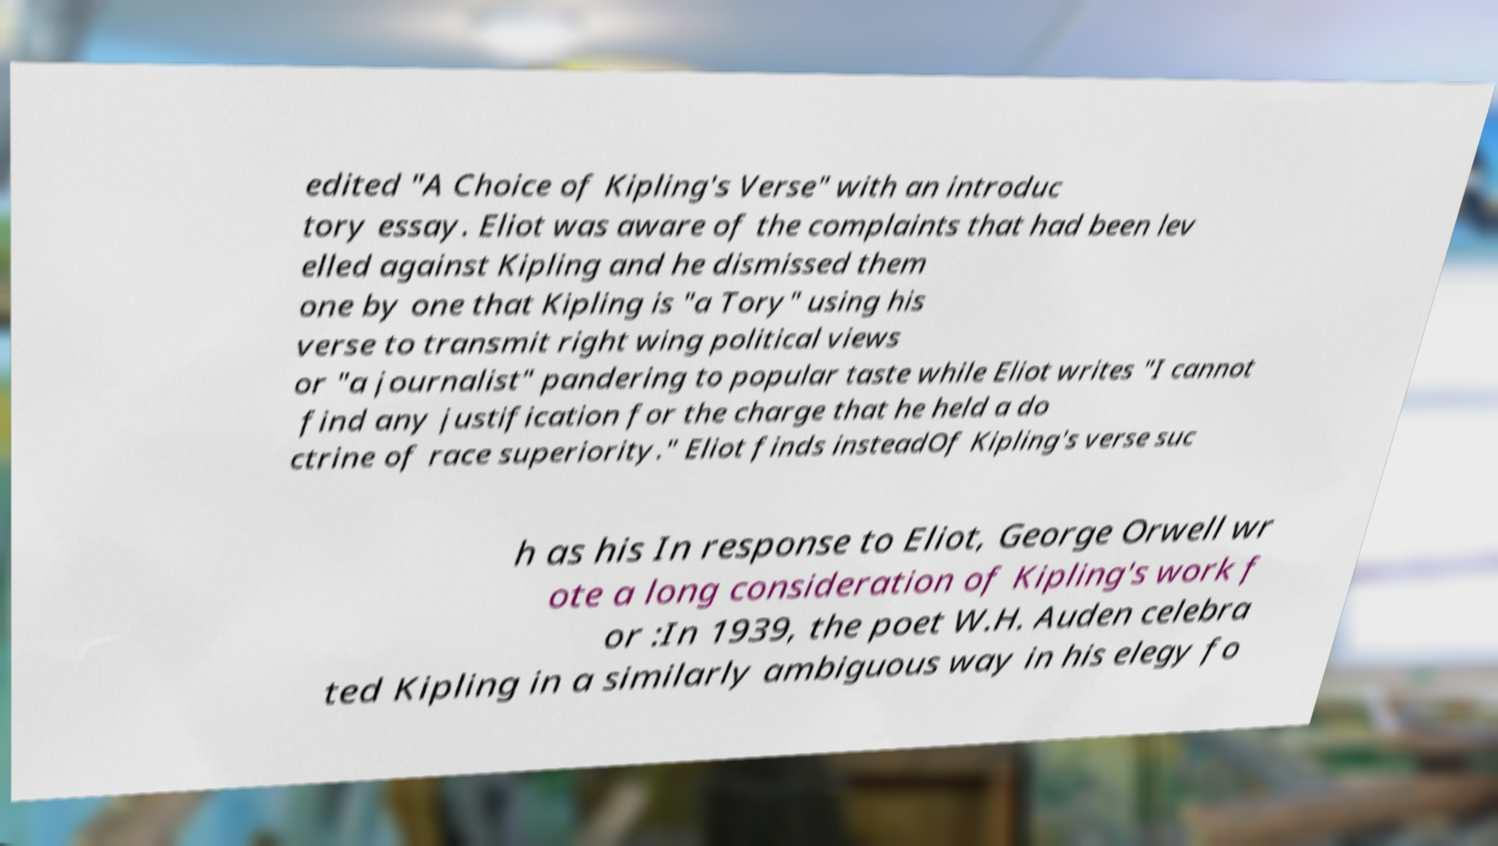There's text embedded in this image that I need extracted. Can you transcribe it verbatim? edited "A Choice of Kipling's Verse" with an introduc tory essay. Eliot was aware of the complaints that had been lev elled against Kipling and he dismissed them one by one that Kipling is "a Tory" using his verse to transmit right wing political views or "a journalist" pandering to popular taste while Eliot writes "I cannot find any justification for the charge that he held a do ctrine of race superiority." Eliot finds insteadOf Kipling's verse suc h as his In response to Eliot, George Orwell wr ote a long consideration of Kipling's work f or :In 1939, the poet W.H. Auden celebra ted Kipling in a similarly ambiguous way in his elegy fo 